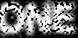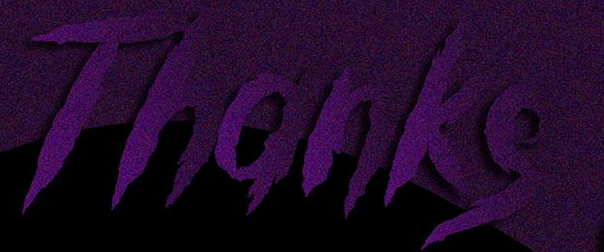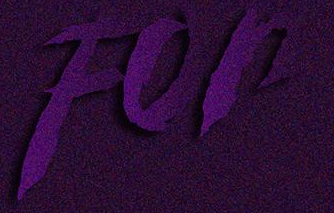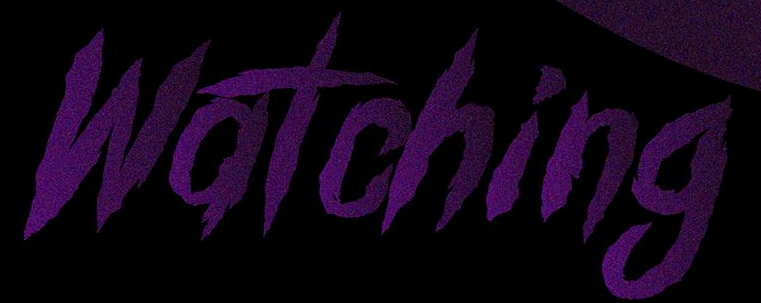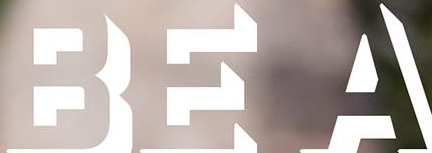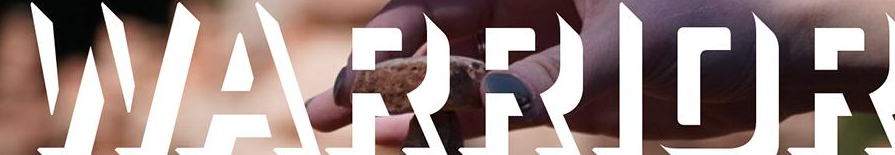Read the text from these images in sequence, separated by a semicolon. ONE; Thanks; For; Watching; BEA; WARRIOR 